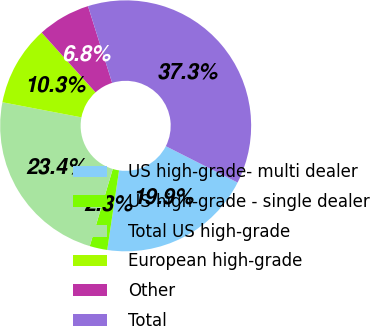Convert chart. <chart><loc_0><loc_0><loc_500><loc_500><pie_chart><fcel>US high-grade- multi dealer<fcel>US high-grade - single dealer<fcel>Total US high-grade<fcel>European high-grade<fcel>Other<fcel>Total<nl><fcel>19.88%<fcel>2.27%<fcel>23.39%<fcel>10.32%<fcel>6.82%<fcel>37.31%<nl></chart> 